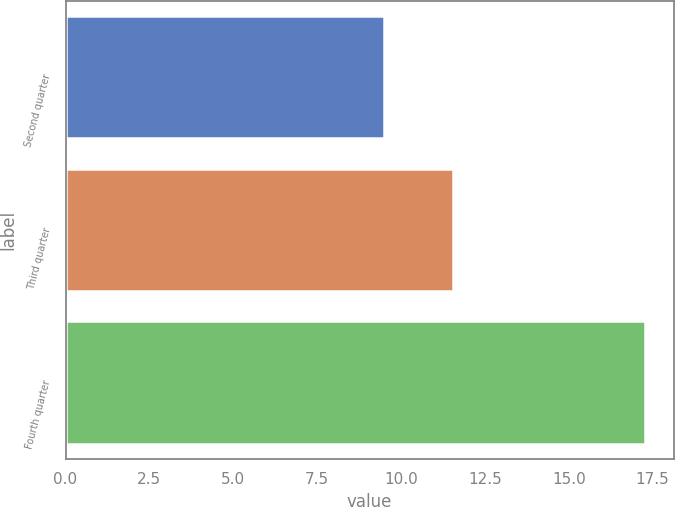<chart> <loc_0><loc_0><loc_500><loc_500><bar_chart><fcel>Second quarter<fcel>Third quarter<fcel>Fourth quarter<nl><fcel>9.48<fcel>11.55<fcel>17.26<nl></chart> 